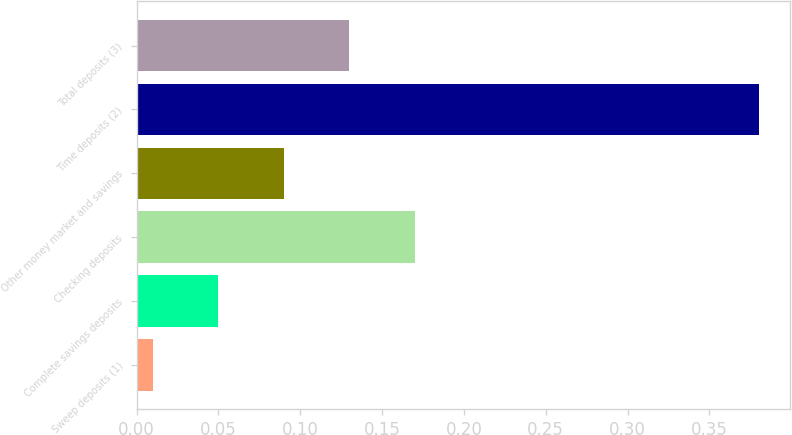Convert chart to OTSL. <chart><loc_0><loc_0><loc_500><loc_500><bar_chart><fcel>Sweep deposits (1)<fcel>Complete savings deposits<fcel>Checking deposits<fcel>Other money market and savings<fcel>Time deposits (2)<fcel>Total deposits (3)<nl><fcel>0.01<fcel>0.05<fcel>0.17<fcel>0.09<fcel>0.38<fcel>0.13<nl></chart> 